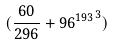<formula> <loc_0><loc_0><loc_500><loc_500>( \frac { 6 0 } { 2 9 6 } + { 9 6 ^ { 1 9 3 } } ^ { 3 } )</formula> 